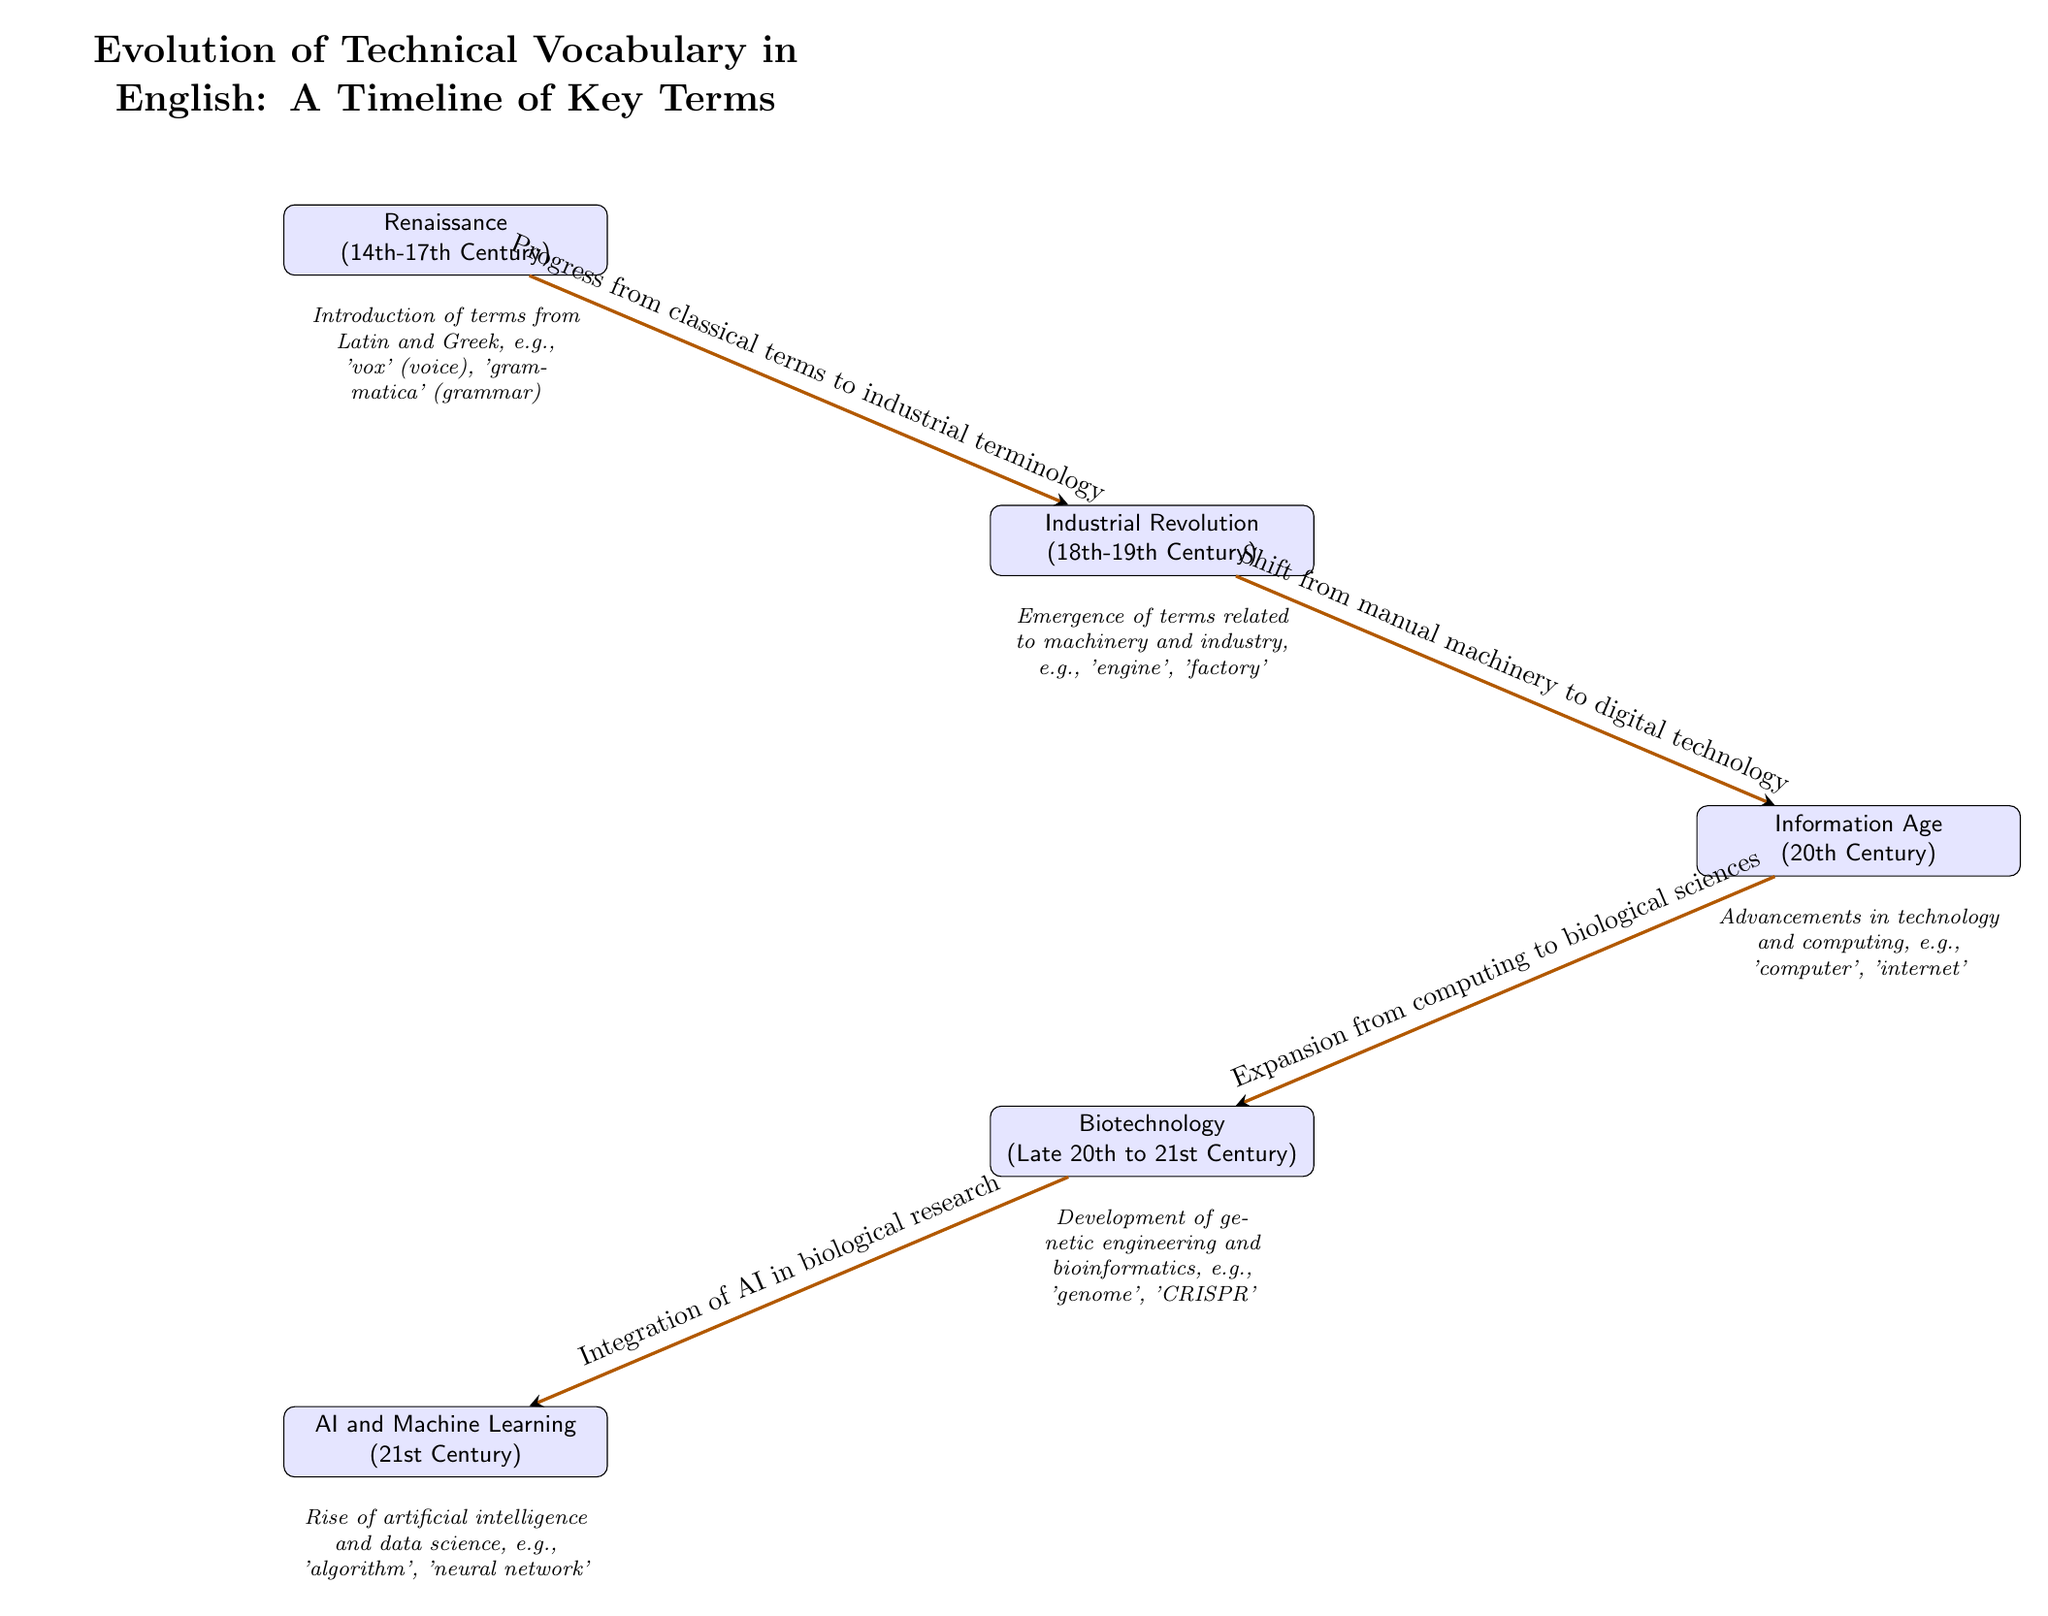What is the earliest period depicted in the timeline? The diagram starts with the Renaissance, which is stated at the top-left node of the timeline.
Answer: Renaissance How many key terms are represented in the diagram? The diagram features five nodes, each representing a different period of vocabulary evolution, thus there are five key terms.
Answer: Five What term is associated with the Industrial Revolution? The term listed under the Industrial Revolution node is 'engine', as specified in the descriptive text below that node.
Answer: engine What type of terminology emerged during the Renaissance? The diagram indicates that the terminology introduced during the Renaissance was from Latin and Greek, specifically named in the description below the node.
Answer: Latin and Greek What is the relationship between the Information Age and Biotechnology? The diagram shows an edge going from Information Age to Biotechnology, indicating a "Expansion from computing to biological sciences." This involves understanding how advancements in one field led to growth in another.
Answer: Expansion from computing to biological sciences Which two key terms are explicitly mentioned under AI and Machine Learning? Under the AI and ML node, the terms 'algorithm' and 'neural network' are listed as significant developments during this period.
Answer: algorithm, neural network What significant shift does the path between Industrial Revolution and Information Age describe? The diagram states that this path is characterized by a "Shift from manual machinery to digital technology," highlighting the transformation in how technology advanced during these periods.
Answer: Shift from manual machinery to digital technology Which century does the Biotechnology era cover? The timeline indicates that the Biotechnology period spans from the late 20th to the 21st century, as described below the Biotechnology node.
Answer: Late 20th to 21st Century What is the main focus of vocabulary evolution during the Information Age? The descriptive text under the Information Age node lists 'Advancements in technology and computing' as the main focus, which defines the type of vocabulary that evolved during this timeframe.
Answer: Advancements in technology and computing 